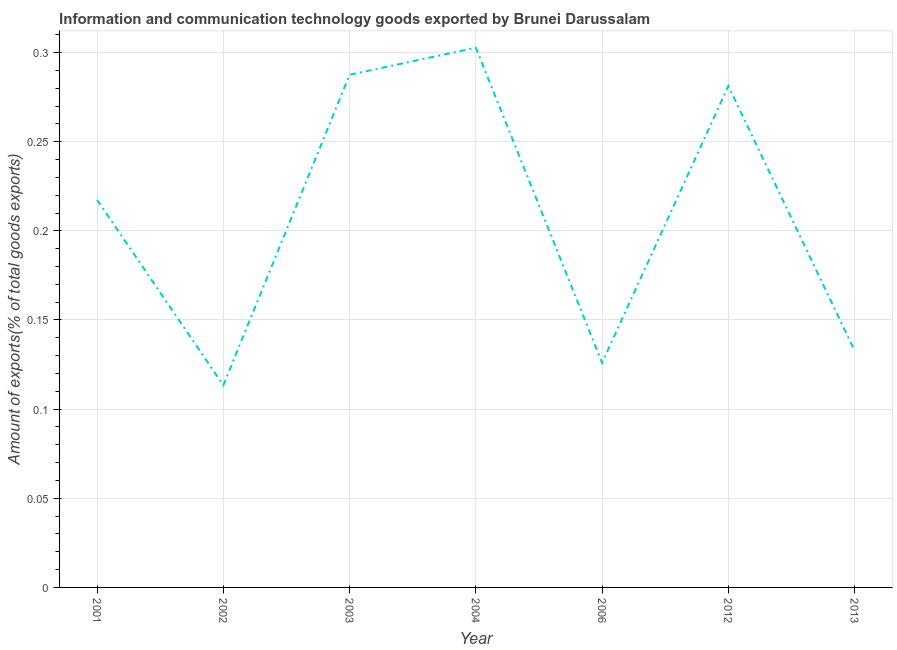What is the amount of ict goods exports in 2013?
Your answer should be very brief. 0.13. Across all years, what is the maximum amount of ict goods exports?
Provide a succinct answer. 0.3. Across all years, what is the minimum amount of ict goods exports?
Provide a short and direct response. 0.11. In which year was the amount of ict goods exports minimum?
Offer a terse response. 2002. What is the sum of the amount of ict goods exports?
Offer a very short reply. 1.46. What is the difference between the amount of ict goods exports in 2001 and 2004?
Your answer should be compact. -0.09. What is the average amount of ict goods exports per year?
Your response must be concise. 0.21. What is the median amount of ict goods exports?
Make the answer very short. 0.22. In how many years, is the amount of ict goods exports greater than 0.26 %?
Make the answer very short. 3. What is the ratio of the amount of ict goods exports in 2003 to that in 2004?
Ensure brevity in your answer.  0.95. What is the difference between the highest and the second highest amount of ict goods exports?
Offer a terse response. 0.02. Is the sum of the amount of ict goods exports in 2004 and 2013 greater than the maximum amount of ict goods exports across all years?
Make the answer very short. Yes. What is the difference between the highest and the lowest amount of ict goods exports?
Keep it short and to the point. 0.19. In how many years, is the amount of ict goods exports greater than the average amount of ict goods exports taken over all years?
Provide a succinct answer. 4. Does the amount of ict goods exports monotonically increase over the years?
Offer a terse response. No. How many lines are there?
Your answer should be very brief. 1. How many years are there in the graph?
Ensure brevity in your answer.  7. Does the graph contain any zero values?
Your answer should be very brief. No. Does the graph contain grids?
Your answer should be compact. Yes. What is the title of the graph?
Provide a short and direct response. Information and communication technology goods exported by Brunei Darussalam. What is the label or title of the Y-axis?
Offer a very short reply. Amount of exports(% of total goods exports). What is the Amount of exports(% of total goods exports) in 2001?
Offer a terse response. 0.22. What is the Amount of exports(% of total goods exports) of 2002?
Provide a succinct answer. 0.11. What is the Amount of exports(% of total goods exports) of 2003?
Provide a short and direct response. 0.29. What is the Amount of exports(% of total goods exports) in 2004?
Offer a very short reply. 0.3. What is the Amount of exports(% of total goods exports) in 2006?
Offer a very short reply. 0.13. What is the Amount of exports(% of total goods exports) in 2012?
Provide a short and direct response. 0.28. What is the Amount of exports(% of total goods exports) in 2013?
Keep it short and to the point. 0.13. What is the difference between the Amount of exports(% of total goods exports) in 2001 and 2002?
Your answer should be very brief. 0.1. What is the difference between the Amount of exports(% of total goods exports) in 2001 and 2003?
Offer a very short reply. -0.07. What is the difference between the Amount of exports(% of total goods exports) in 2001 and 2004?
Offer a terse response. -0.09. What is the difference between the Amount of exports(% of total goods exports) in 2001 and 2006?
Make the answer very short. 0.09. What is the difference between the Amount of exports(% of total goods exports) in 2001 and 2012?
Your answer should be compact. -0.06. What is the difference between the Amount of exports(% of total goods exports) in 2001 and 2013?
Provide a succinct answer. 0.08. What is the difference between the Amount of exports(% of total goods exports) in 2002 and 2003?
Ensure brevity in your answer.  -0.17. What is the difference between the Amount of exports(% of total goods exports) in 2002 and 2004?
Offer a terse response. -0.19. What is the difference between the Amount of exports(% of total goods exports) in 2002 and 2006?
Your response must be concise. -0.01. What is the difference between the Amount of exports(% of total goods exports) in 2002 and 2012?
Keep it short and to the point. -0.17. What is the difference between the Amount of exports(% of total goods exports) in 2002 and 2013?
Offer a terse response. -0.02. What is the difference between the Amount of exports(% of total goods exports) in 2003 and 2004?
Keep it short and to the point. -0.02. What is the difference between the Amount of exports(% of total goods exports) in 2003 and 2006?
Your response must be concise. 0.16. What is the difference between the Amount of exports(% of total goods exports) in 2003 and 2012?
Make the answer very short. 0.01. What is the difference between the Amount of exports(% of total goods exports) in 2003 and 2013?
Offer a terse response. 0.15. What is the difference between the Amount of exports(% of total goods exports) in 2004 and 2006?
Provide a succinct answer. 0.18. What is the difference between the Amount of exports(% of total goods exports) in 2004 and 2012?
Ensure brevity in your answer.  0.02. What is the difference between the Amount of exports(% of total goods exports) in 2004 and 2013?
Provide a succinct answer. 0.17. What is the difference between the Amount of exports(% of total goods exports) in 2006 and 2012?
Your response must be concise. -0.16. What is the difference between the Amount of exports(% of total goods exports) in 2006 and 2013?
Make the answer very short. -0.01. What is the difference between the Amount of exports(% of total goods exports) in 2012 and 2013?
Make the answer very short. 0.15. What is the ratio of the Amount of exports(% of total goods exports) in 2001 to that in 2002?
Keep it short and to the point. 1.92. What is the ratio of the Amount of exports(% of total goods exports) in 2001 to that in 2003?
Offer a terse response. 0.76. What is the ratio of the Amount of exports(% of total goods exports) in 2001 to that in 2004?
Make the answer very short. 0.72. What is the ratio of the Amount of exports(% of total goods exports) in 2001 to that in 2006?
Your response must be concise. 1.73. What is the ratio of the Amount of exports(% of total goods exports) in 2001 to that in 2012?
Make the answer very short. 0.77. What is the ratio of the Amount of exports(% of total goods exports) in 2001 to that in 2013?
Your answer should be compact. 1.64. What is the ratio of the Amount of exports(% of total goods exports) in 2002 to that in 2003?
Give a very brief answer. 0.39. What is the ratio of the Amount of exports(% of total goods exports) in 2002 to that in 2012?
Ensure brevity in your answer.  0.4. What is the ratio of the Amount of exports(% of total goods exports) in 2002 to that in 2013?
Provide a succinct answer. 0.85. What is the ratio of the Amount of exports(% of total goods exports) in 2003 to that in 2006?
Ensure brevity in your answer.  2.28. What is the ratio of the Amount of exports(% of total goods exports) in 2003 to that in 2012?
Your response must be concise. 1.02. What is the ratio of the Amount of exports(% of total goods exports) in 2003 to that in 2013?
Offer a terse response. 2.17. What is the ratio of the Amount of exports(% of total goods exports) in 2004 to that in 2006?
Give a very brief answer. 2.4. What is the ratio of the Amount of exports(% of total goods exports) in 2004 to that in 2012?
Provide a short and direct response. 1.08. What is the ratio of the Amount of exports(% of total goods exports) in 2004 to that in 2013?
Give a very brief answer. 2.28. What is the ratio of the Amount of exports(% of total goods exports) in 2006 to that in 2012?
Make the answer very short. 0.45. What is the ratio of the Amount of exports(% of total goods exports) in 2006 to that in 2013?
Ensure brevity in your answer.  0.95. What is the ratio of the Amount of exports(% of total goods exports) in 2012 to that in 2013?
Your response must be concise. 2.12. 